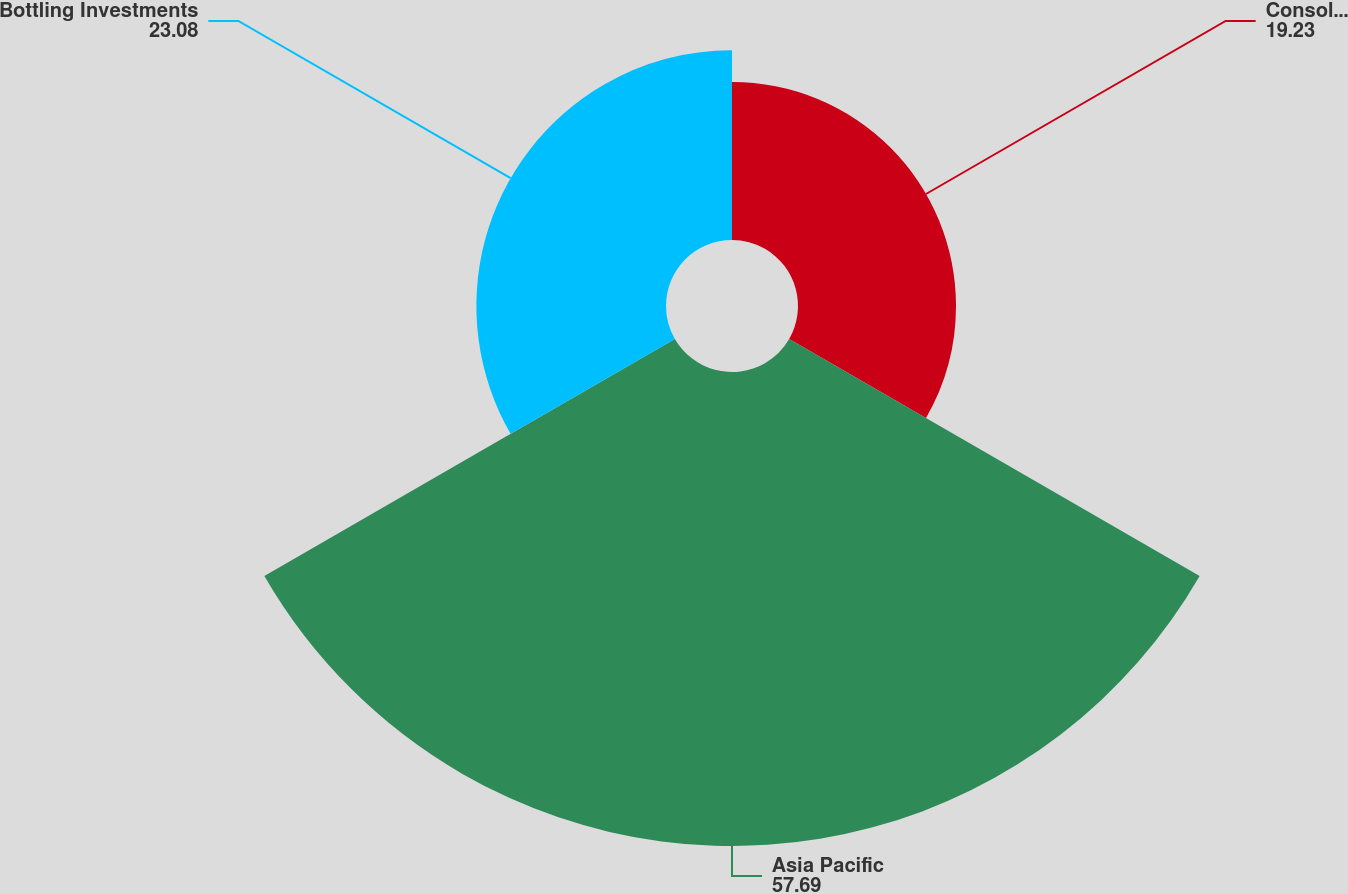<chart> <loc_0><loc_0><loc_500><loc_500><pie_chart><fcel>Consolidated<fcel>Asia Pacific<fcel>Bottling Investments<nl><fcel>19.23%<fcel>57.69%<fcel>23.08%<nl></chart> 